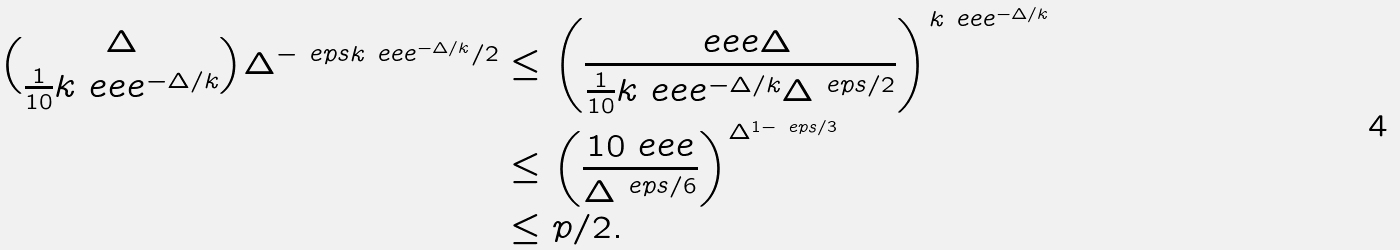Convert formula to latex. <formula><loc_0><loc_0><loc_500><loc_500>\binom { \Delta } { \frac { 1 } { 1 0 } k \ e e e ^ { - \Delta / k } } \Delta ^ { - \ e p s k \ e e e ^ { - \Delta / k } / 2 } & \leq \left ( \frac { \ e e e \Delta } { \frac { 1 } { 1 0 } k \ e e e ^ { - \Delta / k } \Delta ^ { \ e p s / 2 } } \right ) ^ { k \ e e e ^ { - \Delta / k } } \\ & \leq \left ( \frac { 1 0 \ e e e } { \Delta ^ { \ e p s / 6 } } \right ) ^ { \Delta ^ { 1 - \ e p s / 3 } } \\ & \leq p / 2 .</formula> 